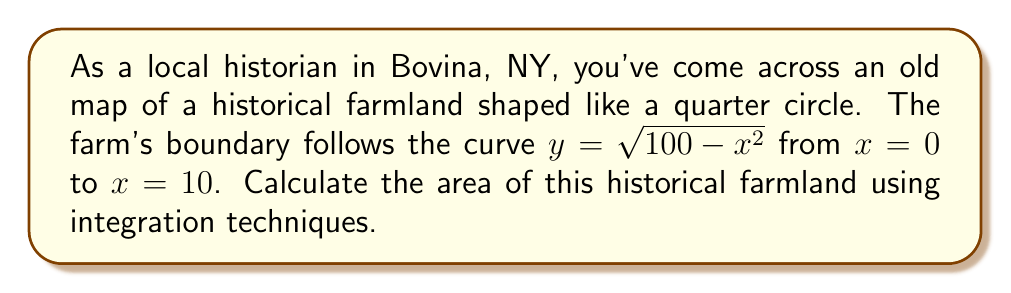Can you answer this question? To calculate the area of this historical farmland, we need to use the technique of integration. The farm is shaped like a quarter circle, which can be represented by the function $y = \sqrt{100 - x^2}$ from $x = 0$ to $x = 10$. Here's how we can solve this problem step by step:

1) The area under a curve is given by the definite integral:

   $$A = \int_{a}^{b} f(x) dx$$

2) In this case, $f(x) = \sqrt{100 - x^2}$, $a = 0$, and $b = 10$. So our integral becomes:

   $$A = \int_{0}^{10} \sqrt{100 - x^2} dx$$

3) This integral is not easily solvable using basic integration techniques. However, we can recognize that this is a quarter of a circle with radius 10. We can use the substitution $x = 10\sin\theta$ to solve it.

4) If $x = 10\sin\theta$, then $dx = 10\cos\theta d\theta$. When $x = 0$, $\theta = 0$, and when $x = 10$, $\theta = \frac{\pi}{2}$.

5) Substituting these into our integral:

   $$A = \int_{0}^{\frac{\pi}{2}} \sqrt{100 - 100\sin^2\theta} \cdot 10\cos\theta d\theta$$

6) Simplify under the square root:

   $$A = \int_{0}^{\frac{\pi}{2}} \sqrt{100\cos^2\theta} \cdot 10\cos\theta d\theta = \int_{0}^{\frac{\pi}{2}} 10\cdot 10\cos^2\theta d\theta = 100\int_{0}^{\frac{\pi}{2}} \cos^2\theta d\theta$$

7) We can solve this using the half-angle formula: $\cos^2\theta = \frac{1 + \cos2\theta}{2}$

   $$A = 100\int_{0}^{\frac{\pi}{2}} \frac{1 + \cos2\theta}{2} d\theta = 50\int_{0}^{\frac{\pi}{2}} (1 + \cos2\theta) d\theta$$

8) Integrate:

   $$A = 50[\theta + \frac{1}{2}\sin2\theta]_{0}^{\frac{\pi}{2}} = 50[\frac{\pi}{2} + 0 - (0 + 0)] = 25\pi$$

Therefore, the area of the historical farmland is $25\pi$ square units (likely square chains or acres, depending on the map's scale).
Answer: $25\pi$ square units 